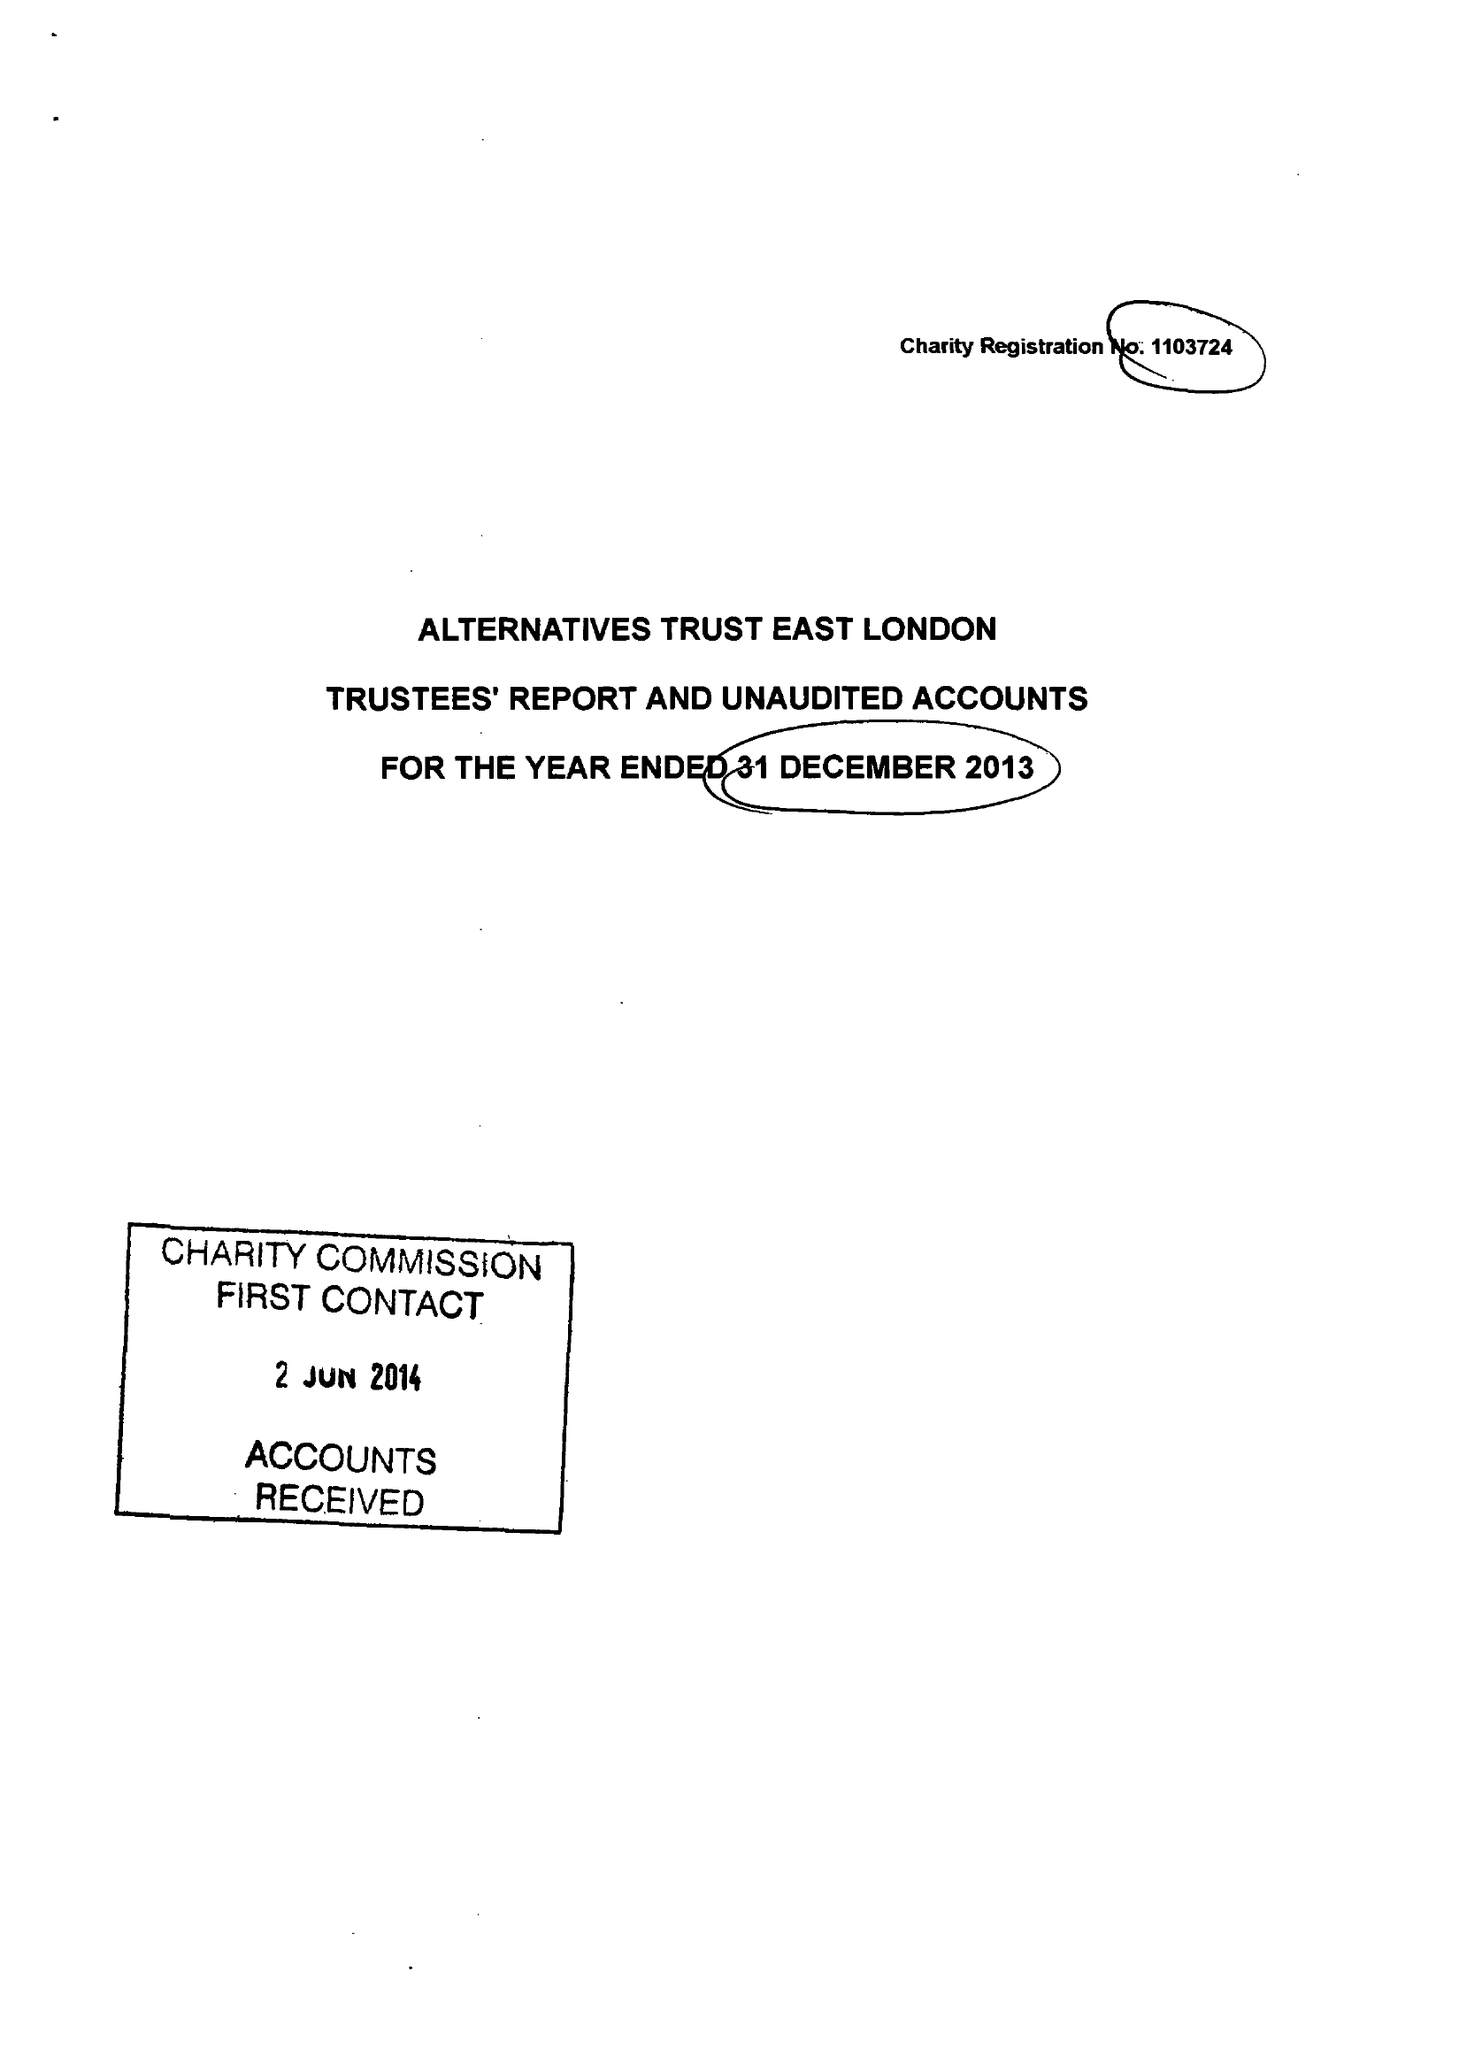What is the value for the address__postcode?
Answer the question using a single word or phrase. E13 8AB 